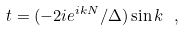Convert formula to latex. <formula><loc_0><loc_0><loc_500><loc_500>t = ( - 2 i e ^ { i k N } / \Delta ) \sin { k } \ ,</formula> 